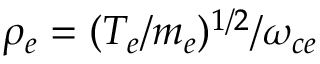Convert formula to latex. <formula><loc_0><loc_0><loc_500><loc_500>\rho _ { e } = ( T _ { e } / m _ { e } ) ^ { 1 / 2 } / \omega _ { c e }</formula> 